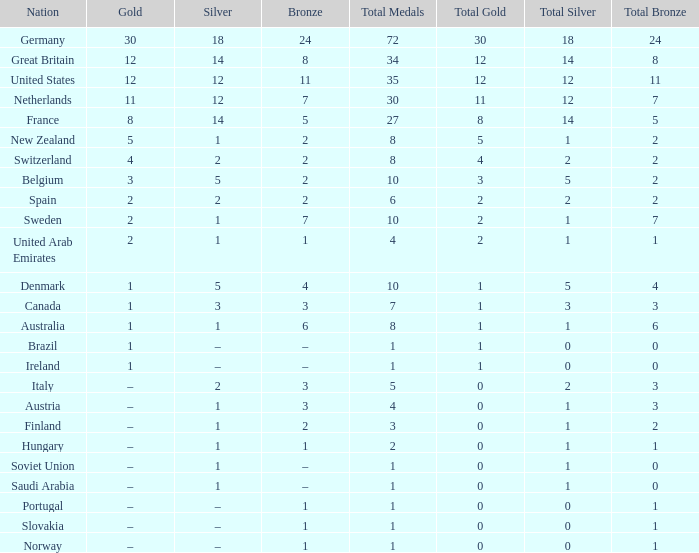What is Bronze, when Silver is 2, and when Nation is Italy? 3.0. 